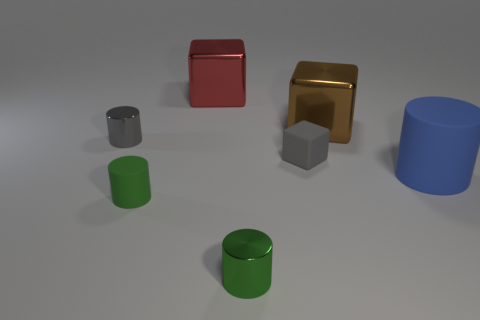What number of small gray cylinders are there?
Ensure brevity in your answer.  1. How many green things are made of the same material as the large cylinder?
Provide a short and direct response. 1. What size is the blue rubber thing that is the same shape as the green shiny thing?
Make the answer very short. Large. What is the material of the blue cylinder?
Ensure brevity in your answer.  Rubber. The blue object behind the green object that is on the left side of the large shiny object that is to the left of the brown thing is made of what material?
Your response must be concise. Rubber. Is there any other thing that is the same shape as the blue rubber thing?
Keep it short and to the point. Yes. There is a big rubber object that is the same shape as the gray shiny object; what color is it?
Your response must be concise. Blue. Is the color of the metal cylinder that is on the right side of the green rubber object the same as the matte cylinder that is on the right side of the large red metallic block?
Keep it short and to the point. No. Is the number of green things on the right side of the big matte object greater than the number of large blue shiny objects?
Give a very brief answer. No. What number of other things are the same size as the red thing?
Keep it short and to the point. 2. 